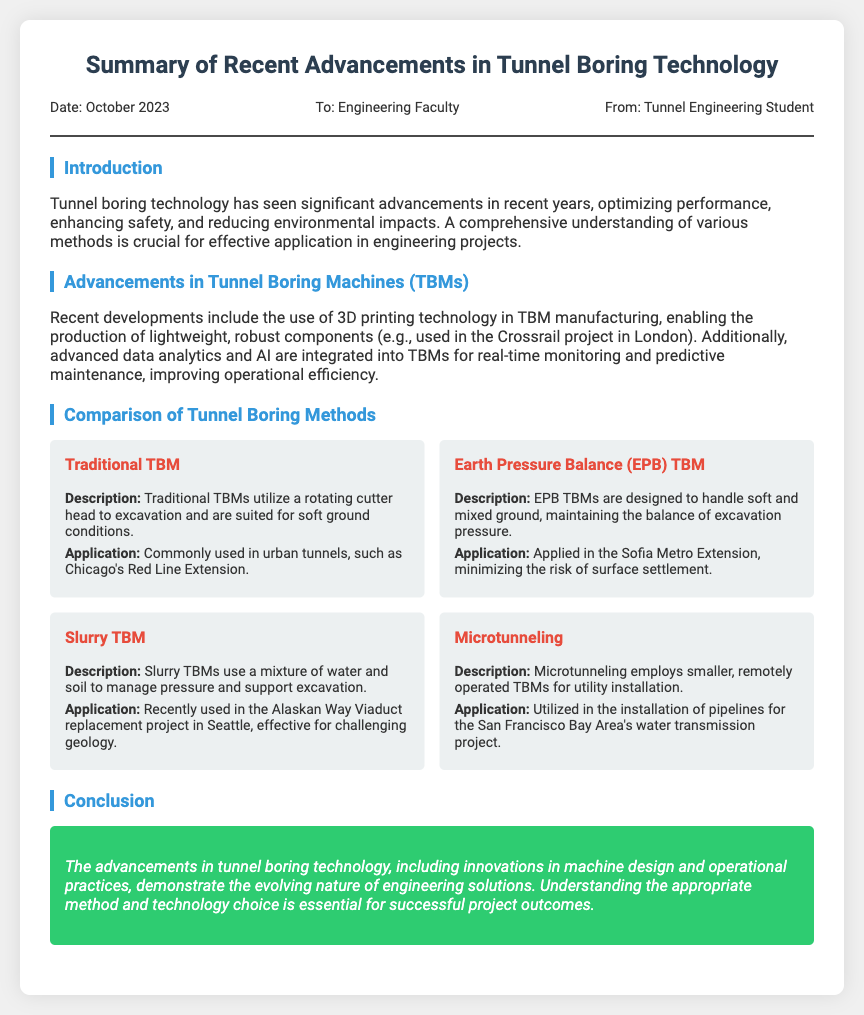what is the date of the memo? The date of the memo is explicitly stated at the top of the document, which is October 2023.
Answer: October 2023 who is the sender of the memo? The memo specifies that it is sent from a Tunnel Engineering Student, as mentioned in the meta section.
Answer: Tunnel Engineering Student what is a key technology used in TBMs? The advancements section notes the integration of advanced data analytics and AI into TBMs for monitoring and maintenance.
Answer: AI which tunnel boring method is suited for soft ground? The document mentions that Traditional TBMs are suited for soft ground conditions.
Answer: Traditional TBM what project utilized Slurry TBM? The Alaskan Way Viaduct replacement project in Seattle used the Slurry TBM as described in the methods section.
Answer: Alaskan Way Viaduct replacement project in which project was Earth Pressure Balance (EPB) TBM applied? The Sofia Metro Extension is identified as a project where EPB TBM was applied to minimize surface settlement risk.
Answer: Sofia Metro Extension what is one advantage of recent TBM advancements? The document highlights that real-time monitoring and predictive maintenance improve operational efficiency of TBMs.
Answer: operational efficiency what type of tunneling method is used for utility installation? The memo states that Microtunneling involves using smaller TBMs for utility installation.
Answer: Microtunneling 